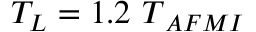<formula> <loc_0><loc_0><loc_500><loc_500>T _ { L } = 1 . 2 { \ T } _ { A F M I }</formula> 